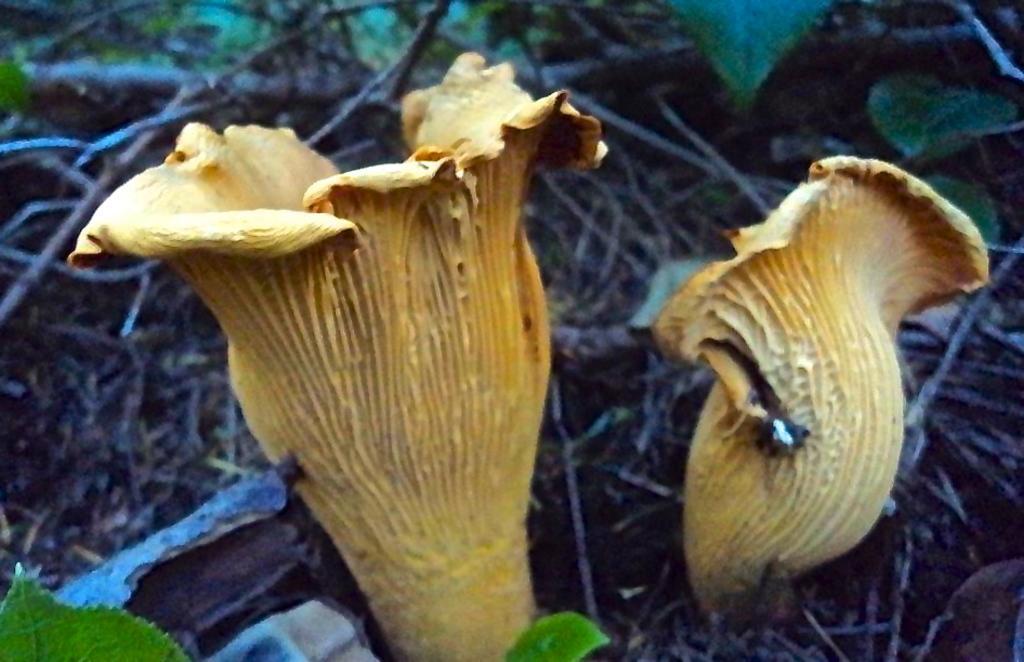Describe this image in one or two sentences. In this image we can see mushrooms. Also there are leaves and sticks. 